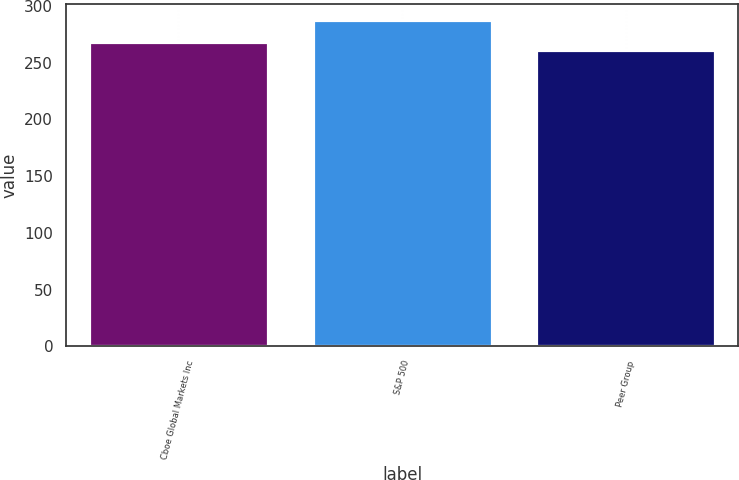Convert chart to OTSL. <chart><loc_0><loc_0><loc_500><loc_500><bar_chart><fcel>Cboe Global Markets Inc<fcel>S&P 500<fcel>Peer Group<nl><fcel>268.31<fcel>287.2<fcel>260.69<nl></chart> 